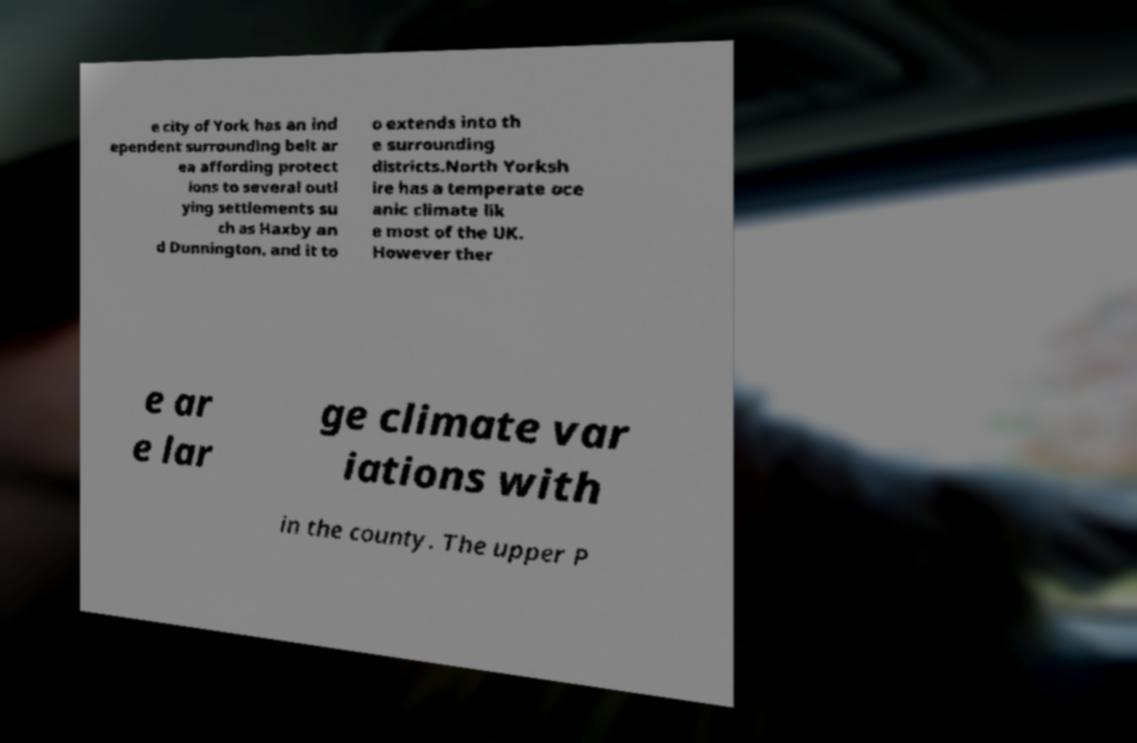Please identify and transcribe the text found in this image. e city of York has an ind ependent surrounding belt ar ea affording protect ions to several outl ying settlements su ch as Haxby an d Dunnington, and it to o extends into th e surrounding districts.North Yorksh ire has a temperate oce anic climate lik e most of the UK. However ther e ar e lar ge climate var iations with in the county. The upper P 